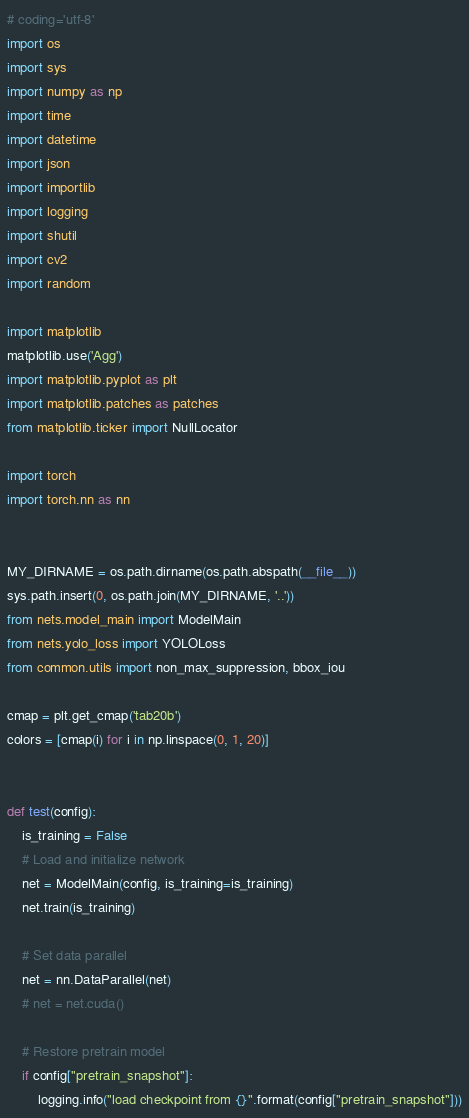Convert code to text. <code><loc_0><loc_0><loc_500><loc_500><_Python_># coding='utf-8'
import os
import sys
import numpy as np
import time
import datetime
import json
import importlib
import logging
import shutil
import cv2
import random

import matplotlib
matplotlib.use('Agg')
import matplotlib.pyplot as plt
import matplotlib.patches as patches
from matplotlib.ticker import NullLocator

import torch
import torch.nn as nn


MY_DIRNAME = os.path.dirname(os.path.abspath(__file__))
sys.path.insert(0, os.path.join(MY_DIRNAME, '..'))
from nets.model_main import ModelMain
from nets.yolo_loss import YOLOLoss
from common.utils import non_max_suppression, bbox_iou

cmap = plt.get_cmap('tab20b')
colors = [cmap(i) for i in np.linspace(0, 1, 20)]


def test(config):
    is_training = False
    # Load and initialize network
    net = ModelMain(config, is_training=is_training)
    net.train(is_training)

    # Set data parallel
    net = nn.DataParallel(net)
    # net = net.cuda()

    # Restore pretrain model
    if config["pretrain_snapshot"]:
        logging.info("load checkpoint from {}".format(config["pretrain_snapshot"]))</code> 